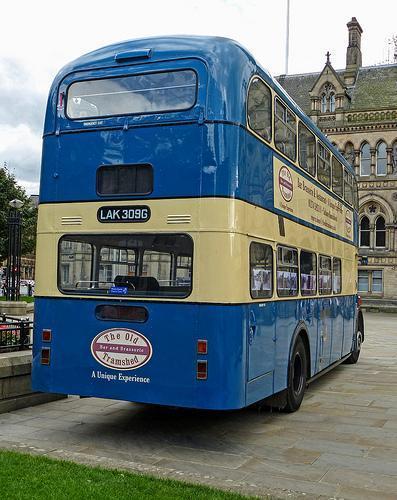How many buses are in the picture?
Give a very brief answer. 1. 